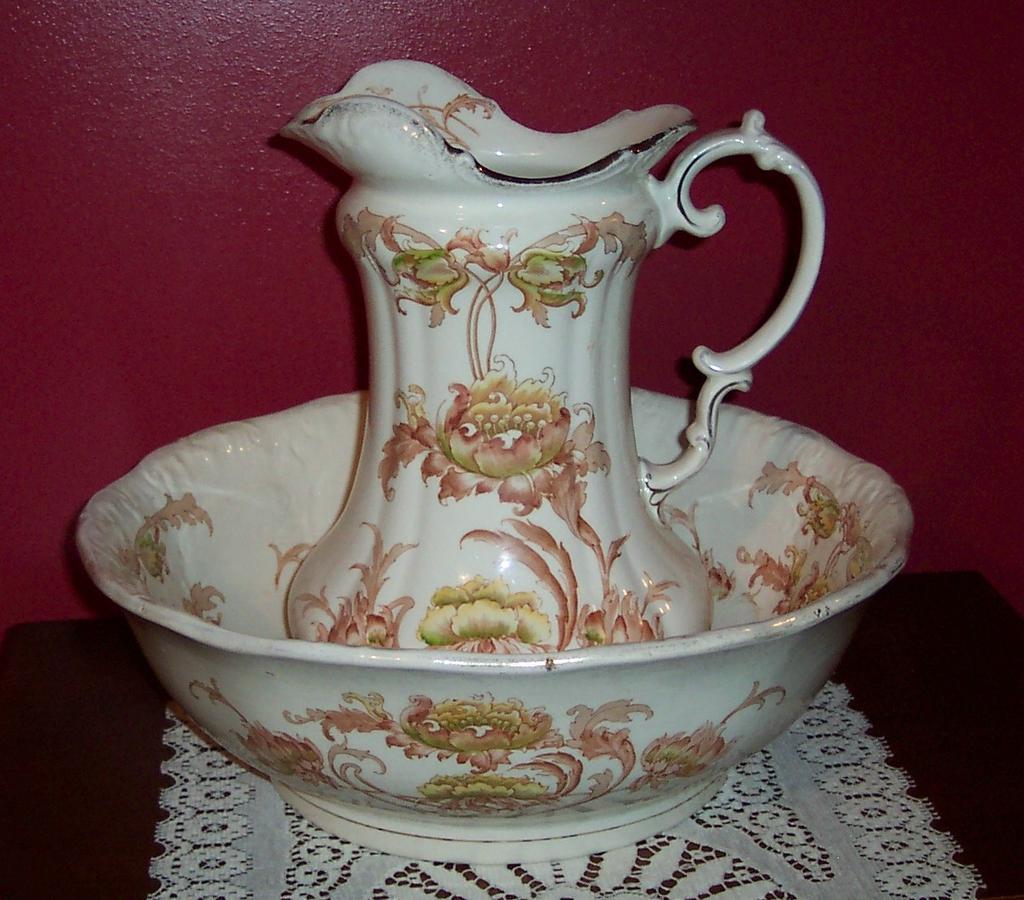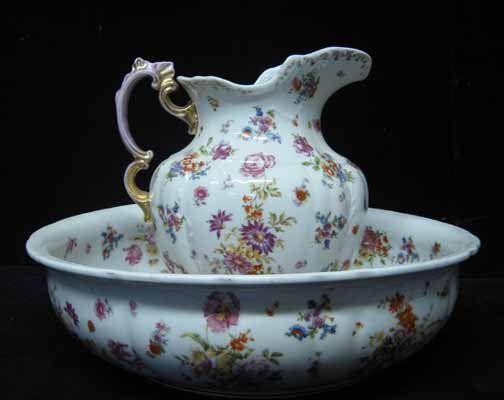The first image is the image on the left, the second image is the image on the right. Assess this claim about the two images: "The spout of every pitcher is facing to the left.". Correct or not? Answer yes or no. No. The first image is the image on the left, the second image is the image on the right. Evaluate the accuracy of this statement regarding the images: "Both handles are on the right side.". Is it true? Answer yes or no. No. 